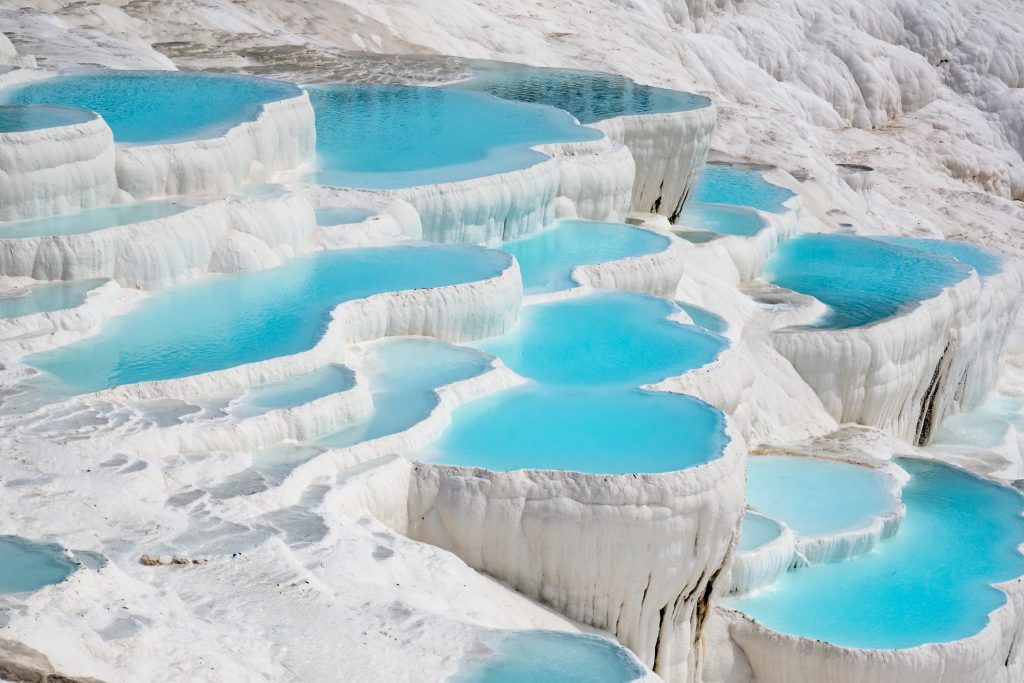Imagine visiting this place in different weather conditions. How might it change? In different weather conditions, Pamukkale's appearance would change dramatically. Under a clear, sunny sky, the blue pools would sparkle, reflecting the sunlight and amplifying their vibrant color against the stark white terraces. During the winter, if snow falls, the scene would transform into a winter wonderland, with the white terraces blending seamlessly into the snowy background, creating a serene and almost surreal landscape. In the rain, the terraces would glisten, and the water's flow might be more pronounced, making the layers look even more dynamic as they cascade down. Finally, at sunset, the changing colors of the sky would cast a magical glow over the terraces, with the white of the travertine and the blue of the pools adopting a warm, golden hue. Each weather condition would provide a unique and breathtaking view of this natural wonder. 
What would it be like to experience Pamukkale at sunrise? Experiencing Pamukkale at sunrise would be truly enchanting. As the first light of dawn touches the terraces, the sky would transition through shades of pink, orange, and gold. The thermal pools would mirror these colors, creating a beautiful, tranquil scene. The early morning light would cast long shadows, accentuating the textures and contours of the terraces. The cooler temperatures and quiet atmosphere would provide a peaceful, almost meditative experience, as you witness the natural wonder waking up to a new day. This early hour would also allow for a more intimate experience, with fewer tourists around, letting you fully immerse in the breathtaking beauty of Pamukkale. 
Can you describe Pamukkale in poetic terms? In the heart of Turkey lies a celestial treasure, Pamukkale, where Earth itself spills secrets of time. Here, sapphire pools nestle in alabaster terraces, cascading like the dreams of ancient waters. The Cotton Castle, woven from nature’s purest threads, stands timeless, whispering tales of its birth from thermal springs. At daybreak, golden hues embrace the white veins of travertine, while dusk paints them in twilight’s tender blush. Pamukkale, a symphony of earth and water, sings softly beneath the sky’s ever-watchful gaze, an ethereal canvas crafted by the hands of eternity. 
Imagine Pamukkale on a bustling market day in an ancient time. What might that look like? On a bustling market day in ancient times, Pamukkale would be a hive of activity. The terraces would serve as a striking backdrop to the lively marketplace, where traders from distant lands gathered to sell their goods. Stalls laden with colorful textiles, fragrant spices, and fresh produce would line the paths. The air would buzz with the sounds of haggling, the laughter of children, and the melodic tunes of local musicians. People in traditional attire would move between the stalls, exchanging stories and news. The hot springs would likely be a central meeting place, where locals and travelers alike might gather to bathe and socialize. The energy of commerce and community would blend harmoniously with the serene beauty of the white terraces and blue pools, creating a vibrant and dynamic scene rich with history and culture. 
What realistic scenario could one imagine when visiting Pamukkale as a tourist? As a tourist visiting Pamukkale, you might start your day early to catch the sunrise over the terraces. The cool morning air and the tranquil atmosphere provide the perfect beginning to your adventure. You walk barefoot along the warm travertine, feeling the unique texture beneath your feet. The water in the pools is refreshingly warm, and you take a moment to soak in one, marveling at the stunning view. Later, you venture to the ancient city of Hierapolis, exploring the well-preserved ruins and the impressive theater. You imagine what life might have been like when this place was a bustling spa town. As the day progresses, you visit the museum to learn more about the site's history and geology. By sunset, you return to the terraces, watching as the colors in the sky reflect in the pools, creating a breathtaking spectacle. The day ends with a leisurely stroll, taking in the serene beauty of Pamukkale under the twilight sky. 
Describe a short but engaging scenario of a visit to Pamukkale. You arrive at Pamukkale just before noon, greeted by the dazzling sight of white terraces and azure pools. Slipping off your shoes, you make your way up the terraces, feeling the warm, slightly rough texture of the travertine underfoot. You pause at one of the shallow pools, dipping your toes into the silky blue water, which is pleasantly warm. After a rejuvenating soak, you explore the nearby ruins of Hierapolis, marveling at the ancient architecture and imagining the bustling activity of the past. As you make your way back down, the sun begins to lower in the sky, casting a golden glow over the terraces, and you take one last look, capturing the moment in your heart before departing. 